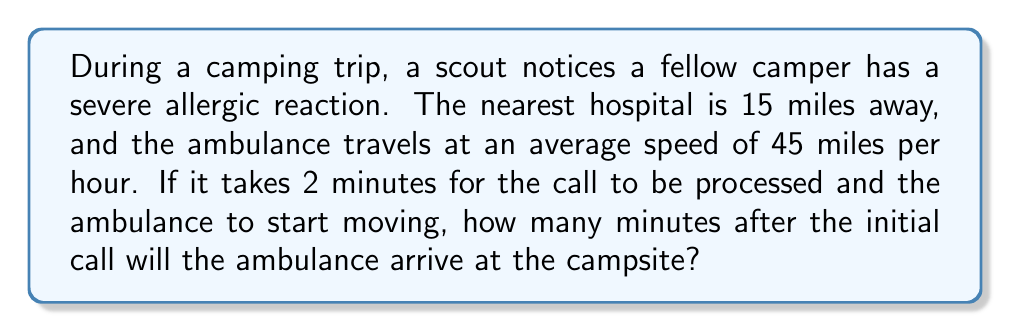What is the answer to this math problem? Let's break this problem down step-by-step:

1. Calculate the time the ambulance spends traveling:
   - Distance = 15 miles
   - Speed = 45 miles per hour
   - Time = Distance ÷ Speed
   $$T = \frac{15 \text{ miles}}{45 \text{ miles/hour}} = \frac{1}{3} \text{ hour}$$

2. Convert the travel time from hours to minutes:
   $$\frac{1}{3} \text{ hour} \times 60 \text{ minutes/hour} = 20 \text{ minutes}$$

3. Add the initial 2-minute delay for call processing:
   $$20 \text{ minutes} + 2 \text{ minutes} = 22 \text{ minutes}$$

Therefore, the ambulance will arrive 22 minutes after the initial call.
Answer: 22 minutes 